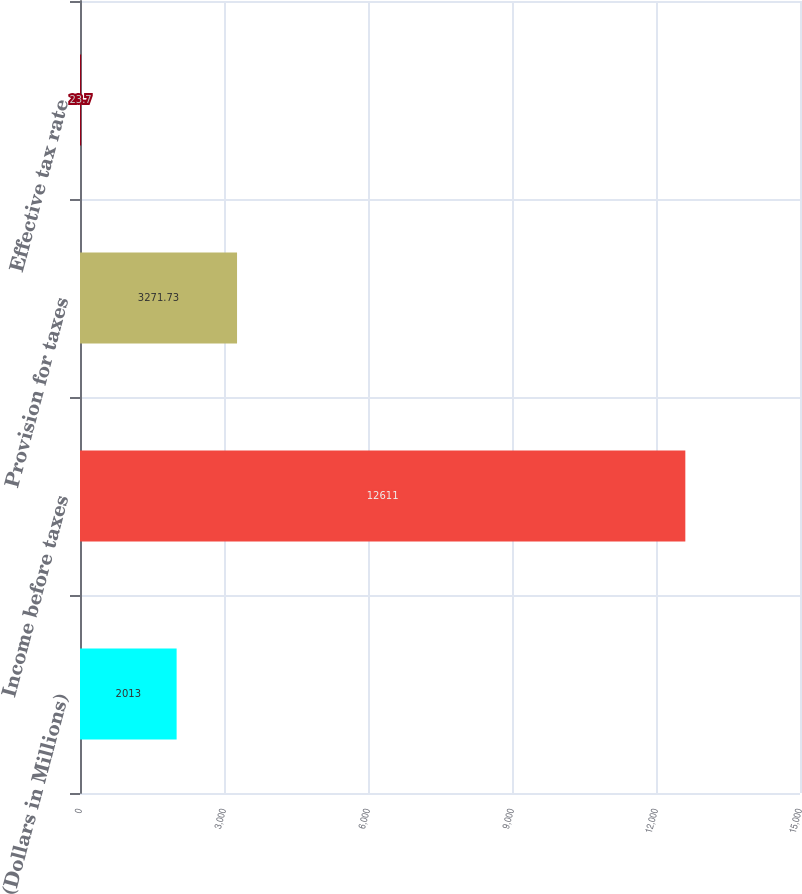Convert chart. <chart><loc_0><loc_0><loc_500><loc_500><bar_chart><fcel>(Dollars in Millions)<fcel>Income before taxes<fcel>Provision for taxes<fcel>Effective tax rate<nl><fcel>2013<fcel>12611<fcel>3271.73<fcel>23.7<nl></chart> 